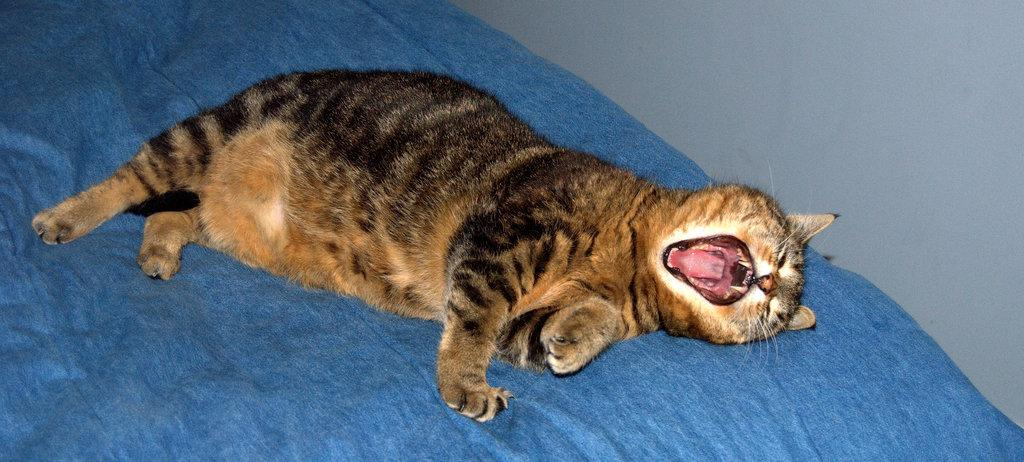What animal is present in the image? There is a cat in the image. What is the cat lying on? The cat is lying on a blue cloth. What can be seen in the background of the image? There is a wall visible in the background of the image. What type of lumber is stacked against the wall in the image? There is no lumber present in the image; it only features a cat lying on a blue cloth with a wall visible in the background. 